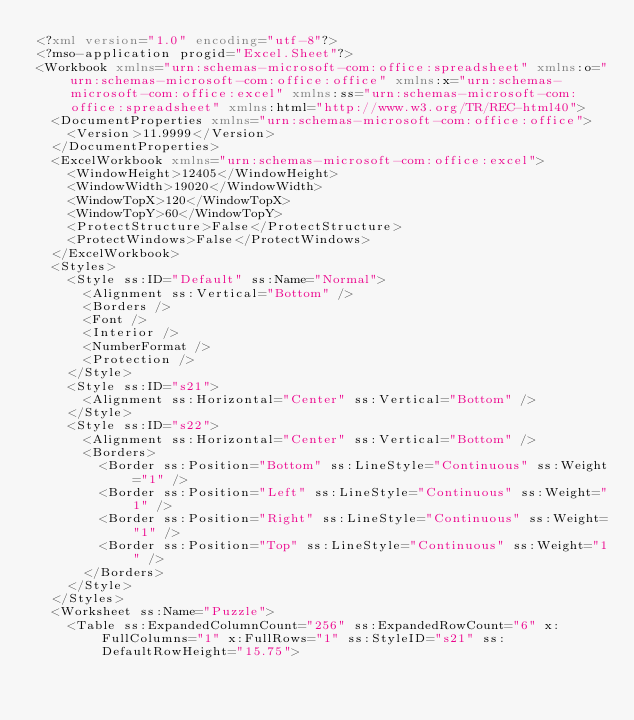<code> <loc_0><loc_0><loc_500><loc_500><_XML_><?xml version="1.0" encoding="utf-8"?>
<?mso-application progid="Excel.Sheet"?>
<Workbook xmlns="urn:schemas-microsoft-com:office:spreadsheet" xmlns:o="urn:schemas-microsoft-com:office:office" xmlns:x="urn:schemas-microsoft-com:office:excel" xmlns:ss="urn:schemas-microsoft-com:office:spreadsheet" xmlns:html="http://www.w3.org/TR/REC-html40">
  <DocumentProperties xmlns="urn:schemas-microsoft-com:office:office">
    <Version>11.9999</Version>
  </DocumentProperties>
  <ExcelWorkbook xmlns="urn:schemas-microsoft-com:office:excel">
    <WindowHeight>12405</WindowHeight>
    <WindowWidth>19020</WindowWidth>
    <WindowTopX>120</WindowTopX>
    <WindowTopY>60</WindowTopY>
    <ProtectStructure>False</ProtectStructure>
    <ProtectWindows>False</ProtectWindows>
  </ExcelWorkbook>
  <Styles>
    <Style ss:ID="Default" ss:Name="Normal">
      <Alignment ss:Vertical="Bottom" />
      <Borders />
      <Font />
      <Interior />
      <NumberFormat />
      <Protection />
    </Style>
    <Style ss:ID="s21">
      <Alignment ss:Horizontal="Center" ss:Vertical="Bottom" />
    </Style>
    <Style ss:ID="s22">
      <Alignment ss:Horizontal="Center" ss:Vertical="Bottom" />
      <Borders>
        <Border ss:Position="Bottom" ss:LineStyle="Continuous" ss:Weight="1" />
        <Border ss:Position="Left" ss:LineStyle="Continuous" ss:Weight="1" />
        <Border ss:Position="Right" ss:LineStyle="Continuous" ss:Weight="1" />
        <Border ss:Position="Top" ss:LineStyle="Continuous" ss:Weight="1" />
      </Borders>
    </Style>
  </Styles>
  <Worksheet ss:Name="Puzzle">
    <Table ss:ExpandedColumnCount="256" ss:ExpandedRowCount="6" x:FullColumns="1" x:FullRows="1" ss:StyleID="s21" ss:DefaultRowHeight="15.75"></code> 